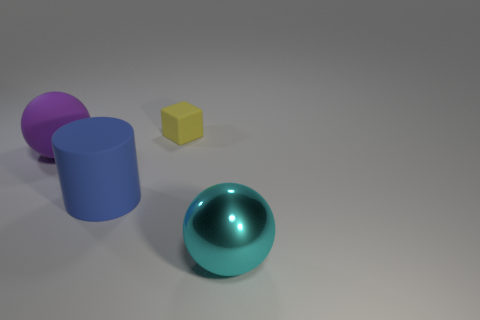Is the number of purple rubber things that are behind the small object the same as the number of matte cubes that are in front of the big blue cylinder? yes 